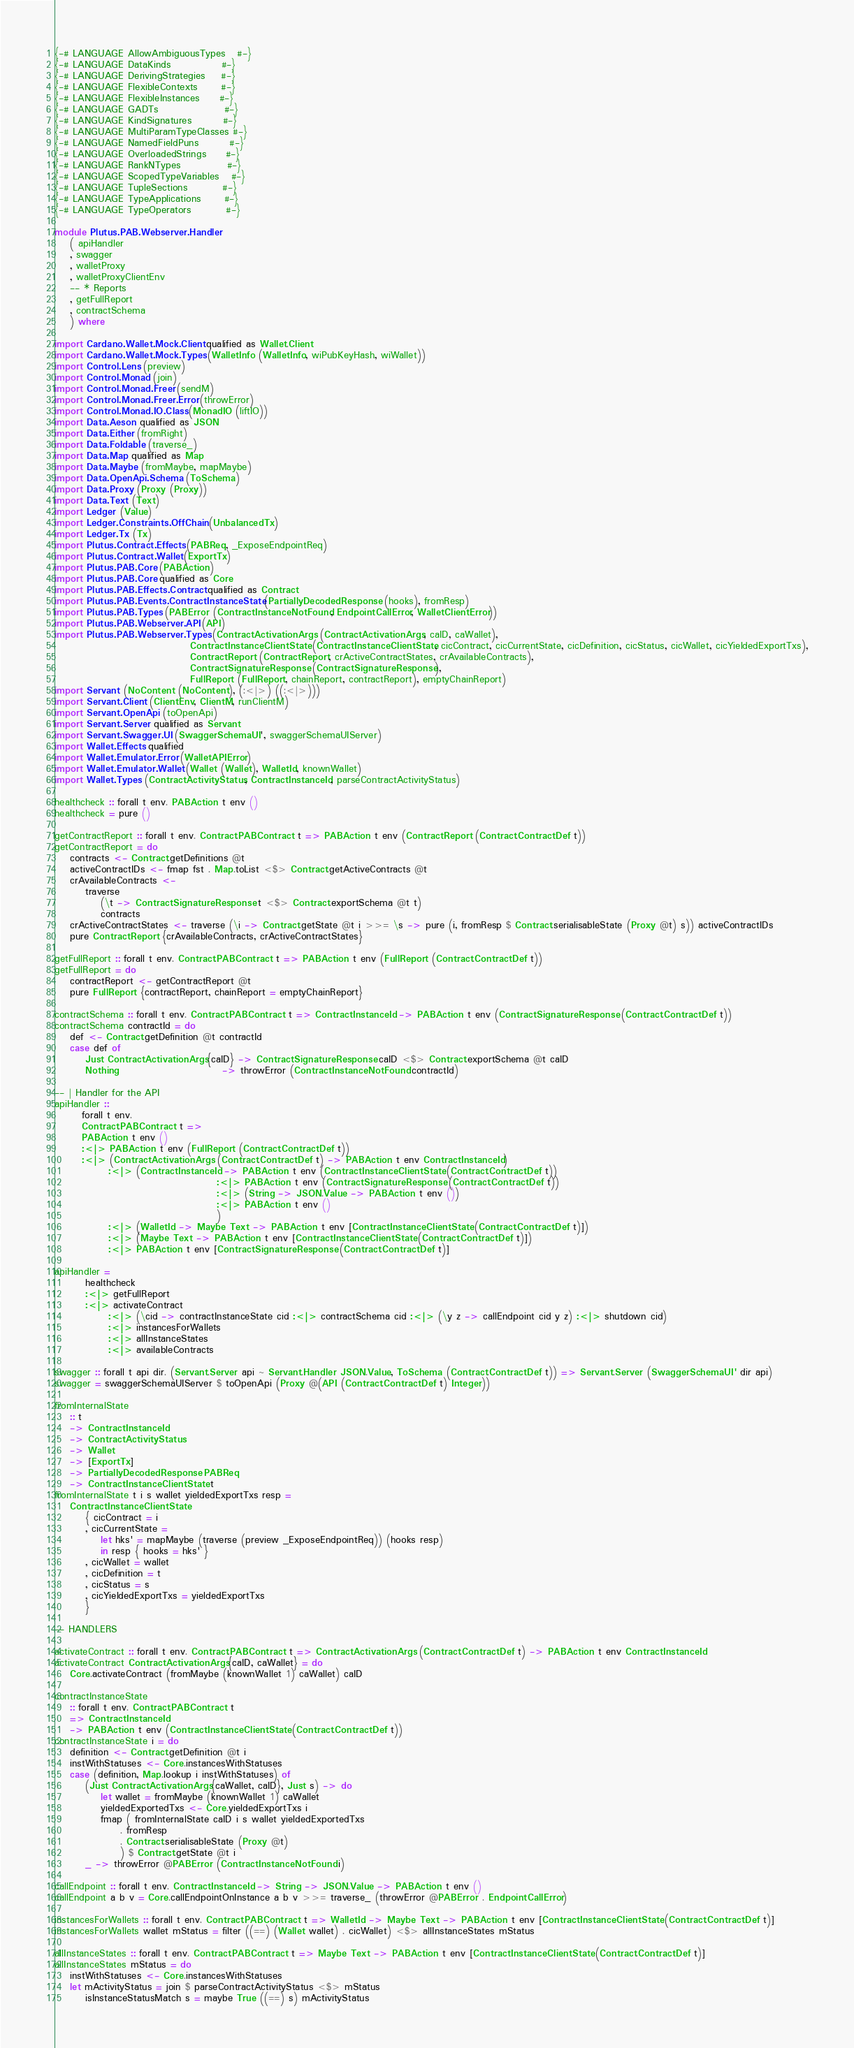<code> <loc_0><loc_0><loc_500><loc_500><_Haskell_>{-# LANGUAGE AllowAmbiguousTypes   #-}
{-# LANGUAGE DataKinds             #-}
{-# LANGUAGE DerivingStrategies    #-}
{-# LANGUAGE FlexibleContexts      #-}
{-# LANGUAGE FlexibleInstances     #-}
{-# LANGUAGE GADTs                 #-}
{-# LANGUAGE KindSignatures        #-}
{-# LANGUAGE MultiParamTypeClasses #-}
{-# LANGUAGE NamedFieldPuns        #-}
{-# LANGUAGE OverloadedStrings     #-}
{-# LANGUAGE RankNTypes            #-}
{-# LANGUAGE ScopedTypeVariables   #-}
{-# LANGUAGE TupleSections         #-}
{-# LANGUAGE TypeApplications      #-}
{-# LANGUAGE TypeOperators         #-}

module Plutus.PAB.Webserver.Handler
    ( apiHandler
    , swagger
    , walletProxy
    , walletProxyClientEnv
    -- * Reports
    , getFullReport
    , contractSchema
    ) where

import Cardano.Wallet.Mock.Client qualified as Wallet.Client
import Cardano.Wallet.Mock.Types (WalletInfo (WalletInfo, wiPubKeyHash, wiWallet))
import Control.Lens (preview)
import Control.Monad (join)
import Control.Monad.Freer (sendM)
import Control.Monad.Freer.Error (throwError)
import Control.Monad.IO.Class (MonadIO (liftIO))
import Data.Aeson qualified as JSON
import Data.Either (fromRight)
import Data.Foldable (traverse_)
import Data.Map qualified as Map
import Data.Maybe (fromMaybe, mapMaybe)
import Data.OpenApi.Schema (ToSchema)
import Data.Proxy (Proxy (Proxy))
import Data.Text (Text)
import Ledger (Value)
import Ledger.Constraints.OffChain (UnbalancedTx)
import Ledger.Tx (Tx)
import Plutus.Contract.Effects (PABReq, _ExposeEndpointReq)
import Plutus.Contract.Wallet (ExportTx)
import Plutus.PAB.Core (PABAction)
import Plutus.PAB.Core qualified as Core
import Plutus.PAB.Effects.Contract qualified as Contract
import Plutus.PAB.Events.ContractInstanceState (PartiallyDecodedResponse (hooks), fromResp)
import Plutus.PAB.Types (PABError (ContractInstanceNotFound, EndpointCallError, WalletClientError))
import Plutus.PAB.Webserver.API (API)
import Plutus.PAB.Webserver.Types (ContractActivationArgs (ContractActivationArgs, caID, caWallet),
                                   ContractInstanceClientState (ContractInstanceClientState, cicContract, cicCurrentState, cicDefinition, cicStatus, cicWallet, cicYieldedExportTxs),
                                   ContractReport (ContractReport, crActiveContractStates, crAvailableContracts),
                                   ContractSignatureResponse (ContractSignatureResponse),
                                   FullReport (FullReport, chainReport, contractReport), emptyChainReport)
import Servant (NoContent (NoContent), (:<|>) ((:<|>)))
import Servant.Client (ClientEnv, ClientM, runClientM)
import Servant.OpenApi (toOpenApi)
import Servant.Server qualified as Servant
import Servant.Swagger.UI (SwaggerSchemaUI', swaggerSchemaUIServer)
import Wallet.Effects qualified
import Wallet.Emulator.Error (WalletAPIError)
import Wallet.Emulator.Wallet (Wallet (Wallet), WalletId, knownWallet)
import Wallet.Types (ContractActivityStatus, ContractInstanceId, parseContractActivityStatus)

healthcheck :: forall t env. PABAction t env ()
healthcheck = pure ()

getContractReport :: forall t env. Contract.PABContract t => PABAction t env (ContractReport (Contract.ContractDef t))
getContractReport = do
    contracts <- Contract.getDefinitions @t
    activeContractIDs <- fmap fst . Map.toList <$> Contract.getActiveContracts @t
    crAvailableContracts <-
        traverse
            (\t -> ContractSignatureResponse t <$> Contract.exportSchema @t t)
            contracts
    crActiveContractStates <- traverse (\i -> Contract.getState @t i >>= \s -> pure (i, fromResp $ Contract.serialisableState (Proxy @t) s)) activeContractIDs
    pure ContractReport {crAvailableContracts, crActiveContractStates}

getFullReport :: forall t env. Contract.PABContract t => PABAction t env (FullReport (Contract.ContractDef t))
getFullReport = do
    contractReport <- getContractReport @t
    pure FullReport {contractReport, chainReport = emptyChainReport}

contractSchema :: forall t env. Contract.PABContract t => ContractInstanceId -> PABAction t env (ContractSignatureResponse (Contract.ContractDef t))
contractSchema contractId = do
    def <- Contract.getDefinition @t contractId
    case def of
        Just ContractActivationArgs{caID} -> ContractSignatureResponse caID <$> Contract.exportSchema @t caID
        Nothing                           -> throwError (ContractInstanceNotFound contractId)

-- | Handler for the API
apiHandler ::
       forall t env.
       Contract.PABContract t =>
       PABAction t env ()
       :<|> PABAction t env (FullReport (Contract.ContractDef t))
       :<|> (ContractActivationArgs (Contract.ContractDef t) -> PABAction t env ContractInstanceId)
              :<|> (ContractInstanceId -> PABAction t env (ContractInstanceClientState (Contract.ContractDef t))
                                          :<|> PABAction t env (ContractSignatureResponse (Contract.ContractDef t))
                                          :<|> (String -> JSON.Value -> PABAction t env ())
                                          :<|> PABAction t env ()
                                          )
              :<|> (WalletId -> Maybe Text -> PABAction t env [ContractInstanceClientState (Contract.ContractDef t)])
              :<|> (Maybe Text -> PABAction t env [ContractInstanceClientState (Contract.ContractDef t)])
              :<|> PABAction t env [ContractSignatureResponse (Contract.ContractDef t)]

apiHandler =
        healthcheck
        :<|> getFullReport
        :<|> activateContract
              :<|> (\cid -> contractInstanceState cid :<|> contractSchema cid :<|> (\y z -> callEndpoint cid y z) :<|> shutdown cid)
              :<|> instancesForWallets
              :<|> allInstanceStates
              :<|> availableContracts

swagger :: forall t api dir. (Servant.Server api ~ Servant.Handler JSON.Value, ToSchema (Contract.ContractDef t)) => Servant.Server (SwaggerSchemaUI' dir api)
swagger = swaggerSchemaUIServer $ toOpenApi (Proxy @(API (Contract.ContractDef t) Integer))

fromInternalState
    :: t
    -> ContractInstanceId
    -> ContractActivityStatus
    -> Wallet
    -> [ExportTx]
    -> PartiallyDecodedResponse PABReq
    -> ContractInstanceClientState t
fromInternalState t i s wallet yieldedExportTxs resp =
    ContractInstanceClientState
        { cicContract = i
        , cicCurrentState =
            let hks' = mapMaybe (traverse (preview _ExposeEndpointReq)) (hooks resp)
            in resp { hooks = hks' }
        , cicWallet = wallet
        , cicDefinition = t
        , cicStatus = s
        , cicYieldedExportTxs = yieldedExportTxs
        }

-- HANDLERS

activateContract :: forall t env. Contract.PABContract t => ContractActivationArgs (Contract.ContractDef t) -> PABAction t env ContractInstanceId
activateContract ContractActivationArgs{caID, caWallet} = do
    Core.activateContract (fromMaybe (knownWallet 1) caWallet) caID

contractInstanceState
    :: forall t env. Contract.PABContract t
    => ContractInstanceId
    -> PABAction t env (ContractInstanceClientState (Contract.ContractDef t))
contractInstanceState i = do
    definition <- Contract.getDefinition @t i
    instWithStatuses <- Core.instancesWithStatuses
    case (definition, Map.lookup i instWithStatuses) of
        (Just ContractActivationArgs{caWallet, caID}, Just s) -> do
            let wallet = fromMaybe (knownWallet 1) caWallet
            yieldedExportedTxs <- Core.yieldedExportTxs i
            fmap ( fromInternalState caID i s wallet yieldedExportedTxs
                 . fromResp
                 . Contract.serialisableState (Proxy @t)
                 ) $ Contract.getState @t i
        _ -> throwError @PABError (ContractInstanceNotFound i)

callEndpoint :: forall t env. ContractInstanceId -> String -> JSON.Value -> PABAction t env ()
callEndpoint a b v = Core.callEndpointOnInstance a b v >>= traverse_ (throwError @PABError . EndpointCallError)

instancesForWallets :: forall t env. Contract.PABContract t => WalletId -> Maybe Text -> PABAction t env [ContractInstanceClientState (Contract.ContractDef t)]
instancesForWallets wallet mStatus = filter ((==) (Wallet wallet) . cicWallet) <$> allInstanceStates mStatus

allInstanceStates :: forall t env. Contract.PABContract t => Maybe Text -> PABAction t env [ContractInstanceClientState (Contract.ContractDef t)]
allInstanceStates mStatus = do
    instWithStatuses <- Core.instancesWithStatuses
    let mActivityStatus = join $ parseContractActivityStatus <$> mStatus
        isInstanceStatusMatch s = maybe True ((==) s) mActivityStatus</code> 